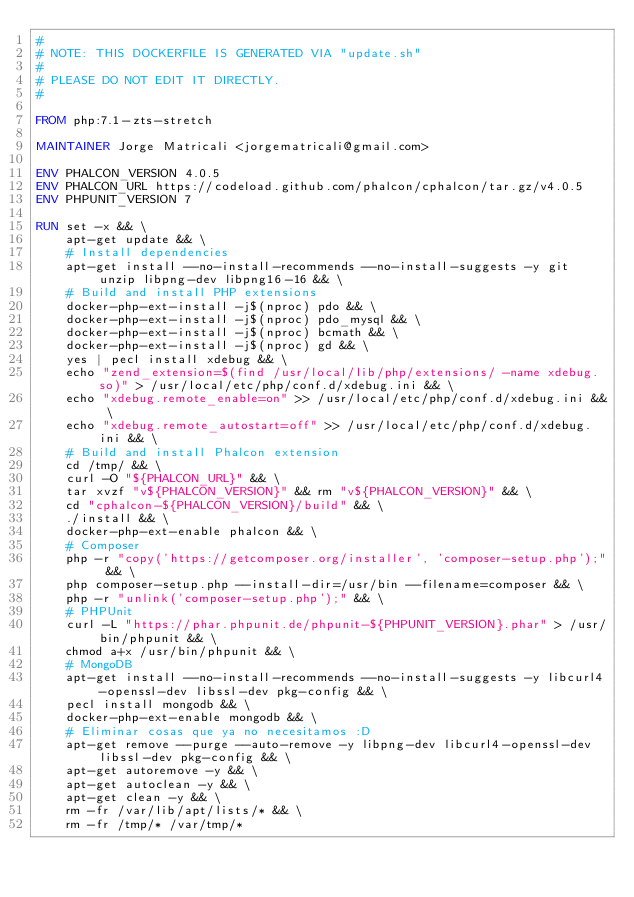Convert code to text. <code><loc_0><loc_0><loc_500><loc_500><_Dockerfile_>#
# NOTE: THIS DOCKERFILE IS GENERATED VIA "update.sh"
#
# PLEASE DO NOT EDIT IT DIRECTLY.
#

FROM php:7.1-zts-stretch

MAINTAINER Jorge Matricali <jorgematricali@gmail.com>

ENV PHALCON_VERSION 4.0.5
ENV PHALCON_URL https://codeload.github.com/phalcon/cphalcon/tar.gz/v4.0.5
ENV PHPUNIT_VERSION 7

RUN set -x && \
    apt-get update && \
    # Install dependencies
    apt-get install --no-install-recommends --no-install-suggests -y git unzip libpng-dev libpng16-16 && \
    # Build and install PHP extensions
    docker-php-ext-install -j$(nproc) pdo && \
    docker-php-ext-install -j$(nproc) pdo_mysql && \
    docker-php-ext-install -j$(nproc) bcmath && \
    docker-php-ext-install -j$(nproc) gd && \
    yes | pecl install xdebug && \
    echo "zend_extension=$(find /usr/local/lib/php/extensions/ -name xdebug.so)" > /usr/local/etc/php/conf.d/xdebug.ini && \
    echo "xdebug.remote_enable=on" >> /usr/local/etc/php/conf.d/xdebug.ini && \
    echo "xdebug.remote_autostart=off" >> /usr/local/etc/php/conf.d/xdebug.ini && \
    # Build and install Phalcon extension
    cd /tmp/ && \
    curl -O "${PHALCON_URL}" && \
    tar xvzf "v${PHALCON_VERSION}" && rm "v${PHALCON_VERSION}" && \
    cd "cphalcon-${PHALCON_VERSION}/build" && \
    ./install && \
    docker-php-ext-enable phalcon && \
    # Composer
    php -r "copy('https://getcomposer.org/installer', 'composer-setup.php');" && \
    php composer-setup.php --install-dir=/usr/bin --filename=composer && \
    php -r "unlink('composer-setup.php');" && \
    # PHPUnit
    curl -L "https://phar.phpunit.de/phpunit-${PHPUNIT_VERSION}.phar" > /usr/bin/phpunit && \
    chmod a+x /usr/bin/phpunit && \
    # MongoDB
    apt-get install --no-install-recommends --no-install-suggests -y libcurl4-openssl-dev libssl-dev pkg-config && \
    pecl install mongodb && \
    docker-php-ext-enable mongodb && \
    # Eliminar cosas que ya no necesitamos :D
    apt-get remove --purge --auto-remove -y libpng-dev libcurl4-openssl-dev libssl-dev pkg-config && \
    apt-get autoremove -y && \
    apt-get autoclean -y && \
    apt-get clean -y && \
    rm -fr /var/lib/apt/lists/* && \
    rm -fr /tmp/* /var/tmp/*
</code> 